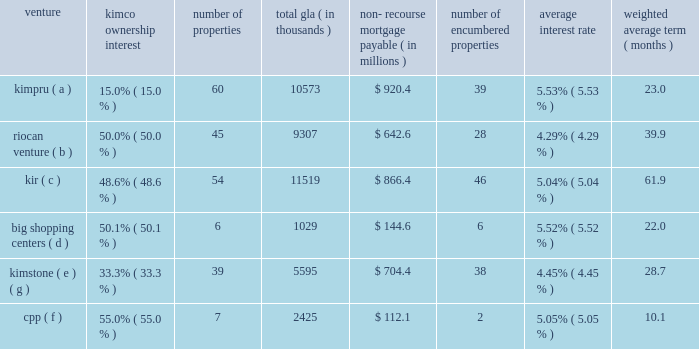Guaranteed by the company with guarantees from the joint venture partners for their proportionate amounts of any guaranty payment the company is obligated to make ( see guarantee table above ) .
Non-recourse mortgage debt is generally defined as debt whereby the lenders 2019 sole recourse with respect to borrower defaults is limited to the value of the property collateralized by the mortgage .
The lender generally does not have recourse against any other assets owned by the borrower or any of the constituent members of the borrower , except for certain specified exceptions listed in the particular loan documents ( see footnote 7 of the notes to consolidated financial statements included in this form 10-k ) .
These investments include the following joint ventures : venture ownership interest number of properties total gla thousands ) recourse mortgage payable ( in millions ) number of encumbered properties average interest weighted average ( months ) .
( a ) represents the company 2019s joint ventures with prudential real estate investors .
( b ) represents the company 2019s joint ventures with riocan real estate investment trust .
( c ) represents the company 2019s joint ventures with certain institutional investors .
( d ) represents the company 2019s remaining joint venture with big shopping centers ( tlv:big ) , an israeli public company ( see footnote 7 of the notes to consolidated financial statements included in this form 10-k ) .
( e ) represents the company 2019s joint ventures with blackstone .
( f ) represents the company 2019s joint ventures with the canadian pension plan investment board ( cppib ) .
( g ) on february 2 , 2015 , the company purchased the remaining 66.7% ( 66.7 % ) interest in the 39-property kimstone portfolio for a gross purchase price of $ 1.4 billion , including the assumption of $ 638.0 million in mortgage debt ( see footnote 26 of the notes to consolidated financial statements included in this form 10-k ) .
The company has various other unconsolidated real estate joint ventures with varying structures .
As of december 31 , 2014 , these other unconsolidated joint ventures had individual non-recourse mortgage loans aggregating $ 1.2 billion .
The aggregate debt as of december 31 , 2014 , of all of the company 2019s unconsolidated real estate joint ventures is $ 4.6 billion , of which the company 2019s proportionate share of this debt is $ 1.8 billion .
As of december 31 , 2014 , these loans had scheduled maturities ranging from one month to 19 years and bear interest at rates ranging from 1.92% ( 1.92 % ) to 8.39% ( 8.39 % ) .
Approximately $ 525.7 million of the aggregate outstanding loan balance matures in 2015 , of which the company 2019s proportionate share is $ 206.0 million .
These maturing loans are anticipated to be repaid with operating cash flows , debt refinancing and partner capital contributions , as deemed appropriate ( see footnote 7 of the notes to consolidated financial statements included in this form 10-k ) . .
What is the company's proportional share of debt from real estate joint ventures ? [14] : the aggregate debt as of december 31 , 2014 , of all of the company 2019s unconsolidated real estate joint ventures is $ 4.6 billion , of which the company 2019s proportionate share of this debt is $ 1.8 billion .? 
Computations: (1.8 + 4.6)
Answer: 6.4. 